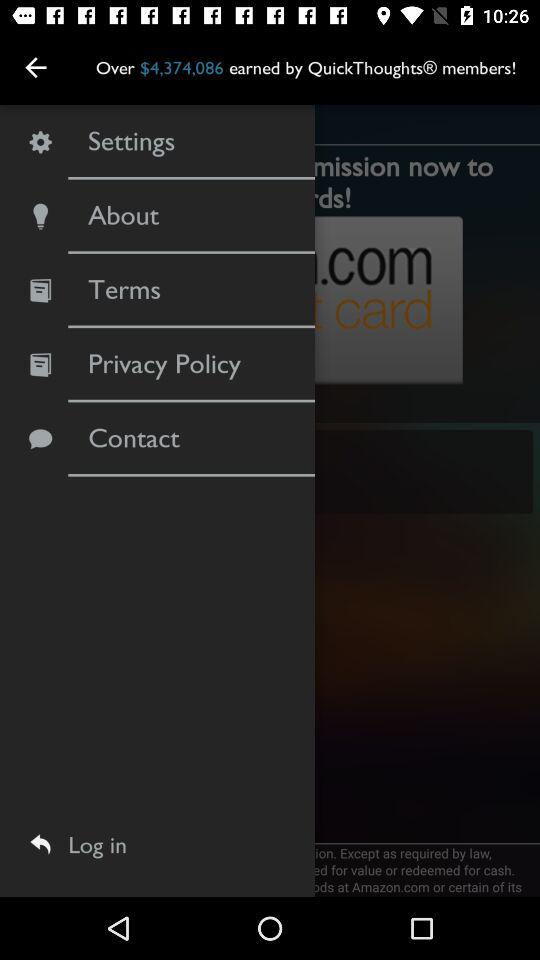How much have the "QuickThoughts" members earned? The "QuickThoughts" members have earned over $4,374,086. 